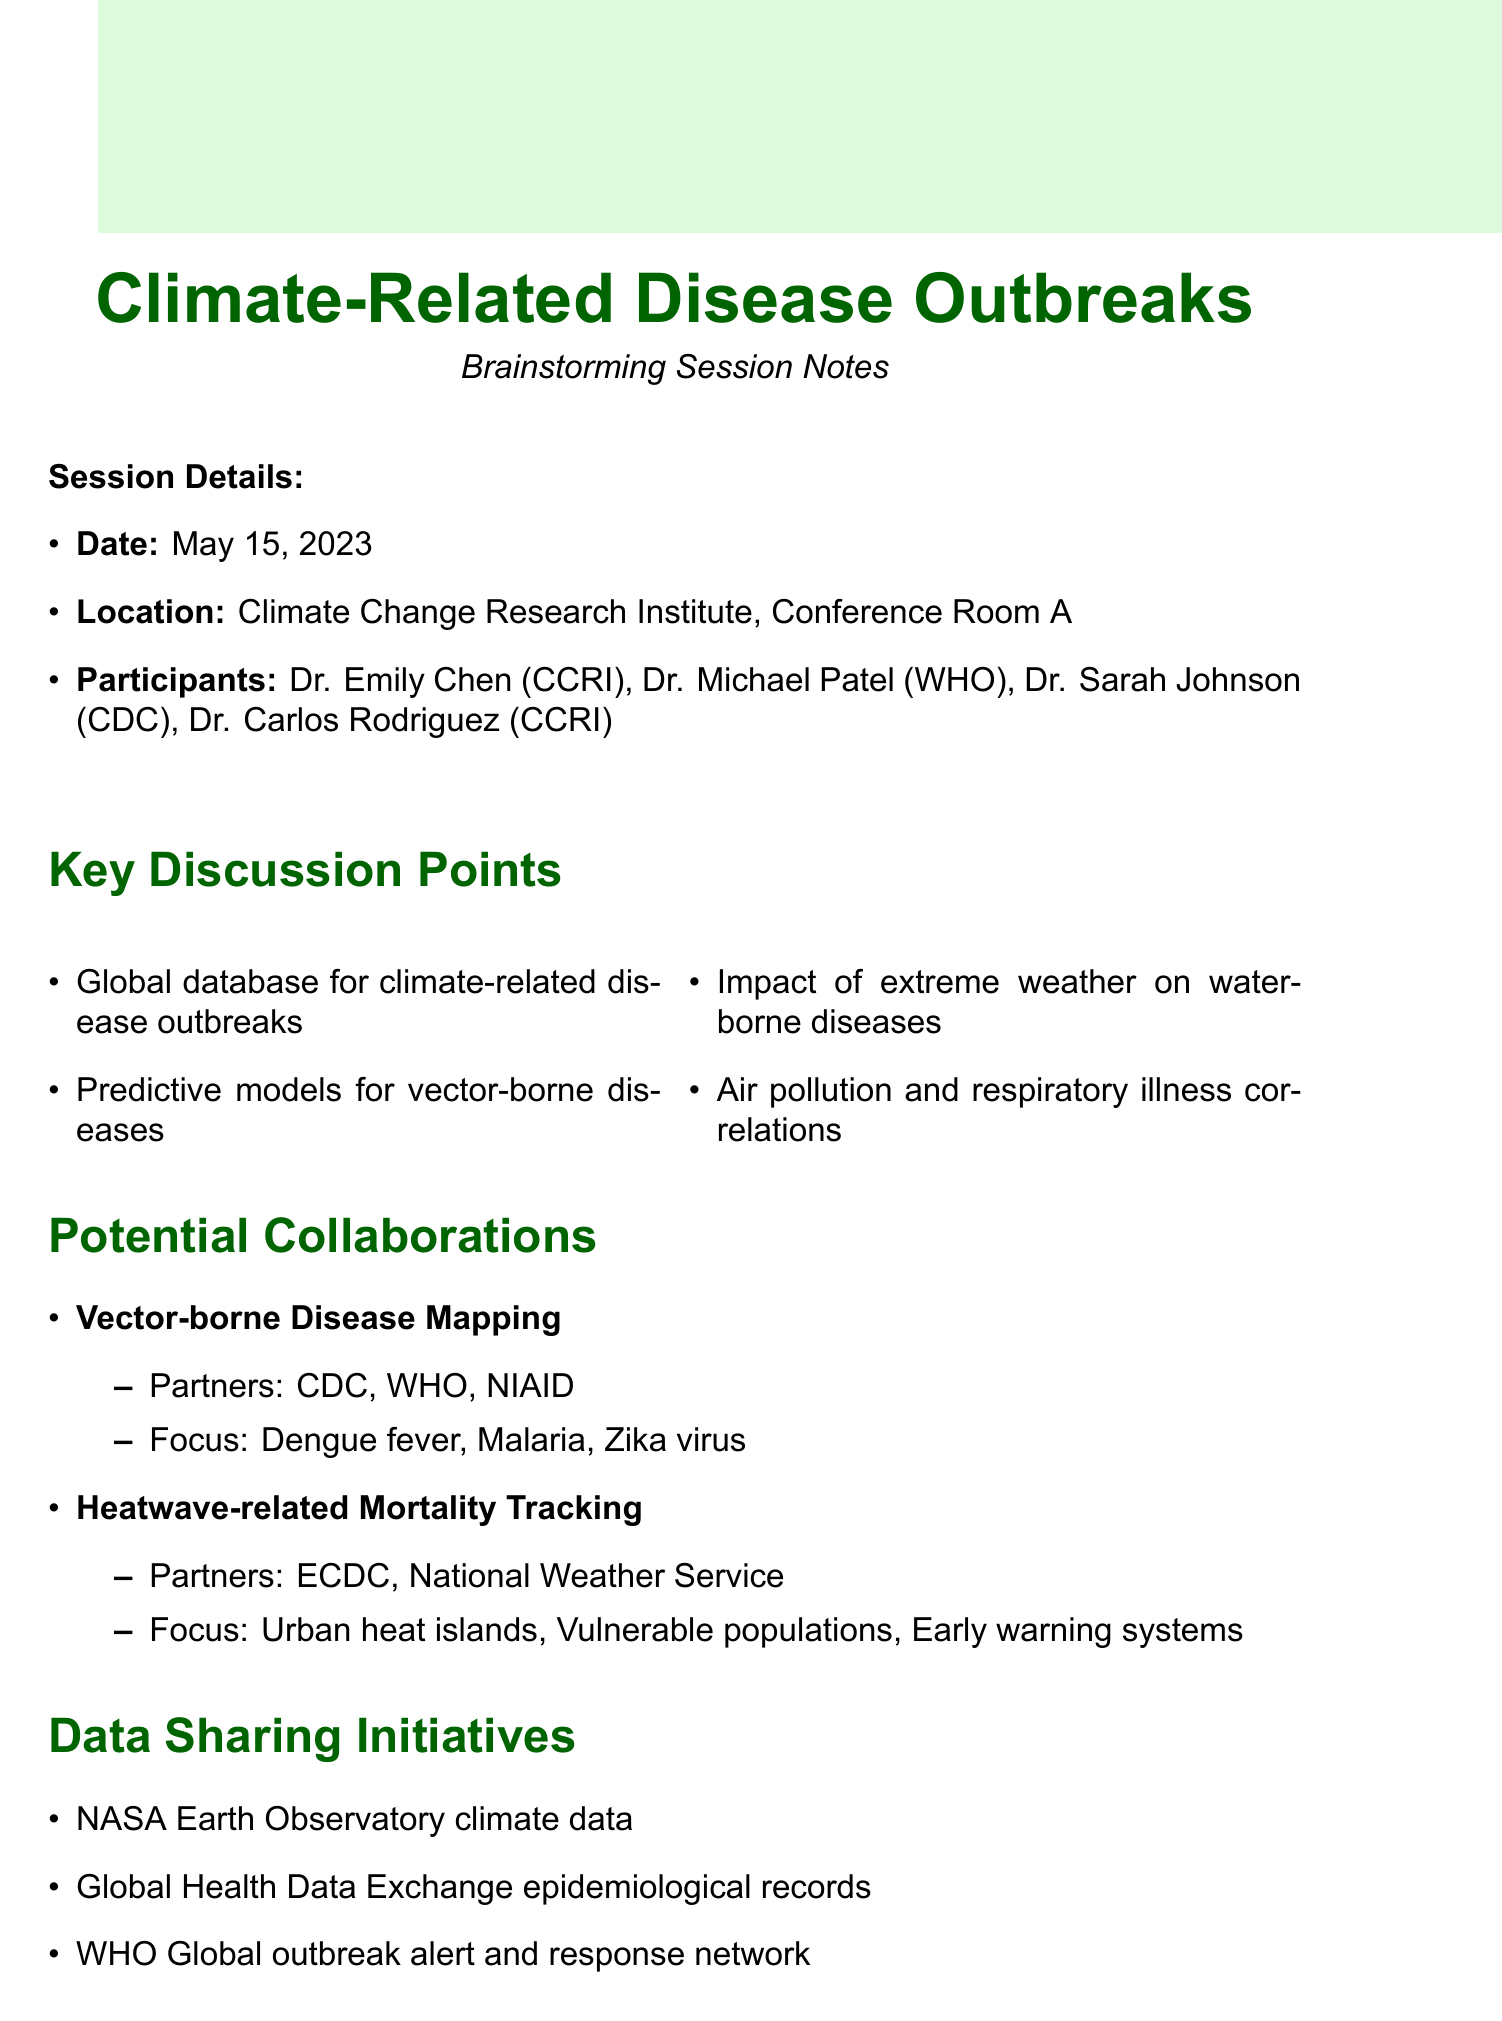What is the date of the brainstorming session? The date of the session is explicitly mentioned in the document under session details.
Answer: May 15, 2023 Who are the participants from CCRI? The document lists the participants from CCRI in the session details section.
Answer: Dr. Emily Chen, Dr. Carlos Rodriguez What is one of the key discussion points regarding air pollution? The discussion point related to air pollution is specified in the key discussion points section.
Answer: Air pollution and respiratory illness correlations Which organization is a partner for the Heatwave-related Mortality Tracking project? The partners for the project are listed under potential collaborations in the document.
Answer: European Centre for Disease Prevention and Control What type of analysis is used for outbreak prediction? The research methodologies section identifies the specific analysis planned for outbreak prediction.
Answer: Machine learning algorithms What is one funding opportunity mentioned in the document? Funding opportunities are listed in a dedicated section of the document.
Answer: NIH Climate Change and Health Initiative grants What are the next steps listed in the document? The next steps are outlined at the end of the document.
Answer: Draft joint research proposal for CDC collaboration How many potential collaborations are outlined in the notes? The number of potential collaborations can be counted from the potential collaborations section.
Answer: Two 